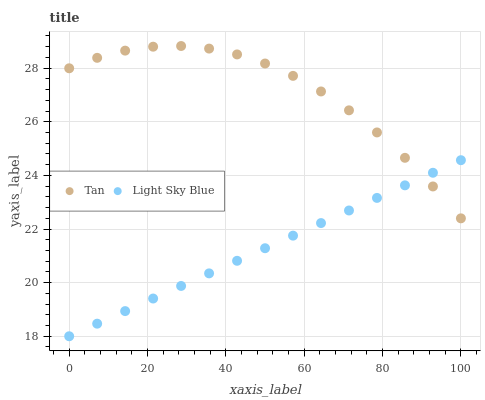Does Light Sky Blue have the minimum area under the curve?
Answer yes or no. Yes. Does Tan have the maximum area under the curve?
Answer yes or no. Yes. Does Light Sky Blue have the maximum area under the curve?
Answer yes or no. No. Is Light Sky Blue the smoothest?
Answer yes or no. Yes. Is Tan the roughest?
Answer yes or no. Yes. Is Light Sky Blue the roughest?
Answer yes or no. No. Does Light Sky Blue have the lowest value?
Answer yes or no. Yes. Does Tan have the highest value?
Answer yes or no. Yes. Does Light Sky Blue have the highest value?
Answer yes or no. No. Does Light Sky Blue intersect Tan?
Answer yes or no. Yes. Is Light Sky Blue less than Tan?
Answer yes or no. No. Is Light Sky Blue greater than Tan?
Answer yes or no. No. 